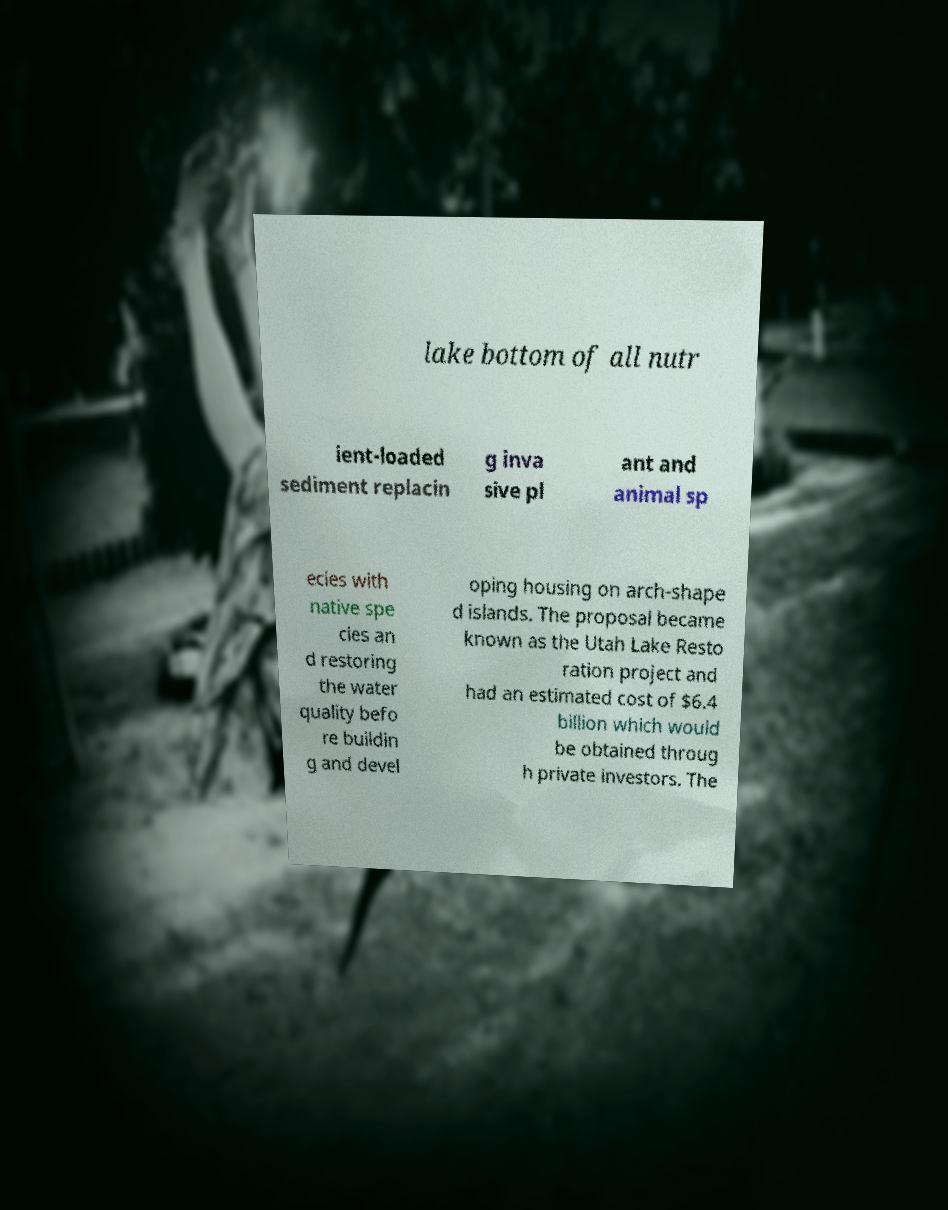What messages or text are displayed in this image? I need them in a readable, typed format. lake bottom of all nutr ient-loaded sediment replacin g inva sive pl ant and animal sp ecies with native spe cies an d restoring the water quality befo re buildin g and devel oping housing on arch-shape d islands. The proposal became known as the Utah Lake Resto ration project and had an estimated cost of $6.4 billion which would be obtained throug h private investors. The 